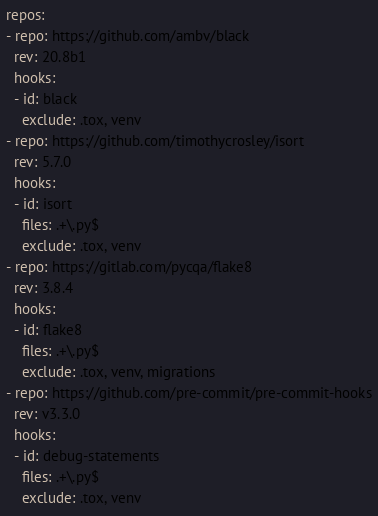<code> <loc_0><loc_0><loc_500><loc_500><_YAML_>repos:
- repo: https://github.com/ambv/black
  rev: 20.8b1
  hooks:
  - id: black
    exclude: .tox, venv
- repo: https://github.com/timothycrosley/isort
  rev: 5.7.0
  hooks:
  - id: isort
    files: .+\.py$
    exclude: .tox, venv
- repo: https://gitlab.com/pycqa/flake8
  rev: 3.8.4
  hooks:
  - id: flake8
    files: .+\.py$
    exclude: .tox, venv, migrations
- repo: https://github.com/pre-commit/pre-commit-hooks
  rev: v3.3.0
  hooks:
  - id: debug-statements
    files: .+\.py$
    exclude: .tox, venv</code> 